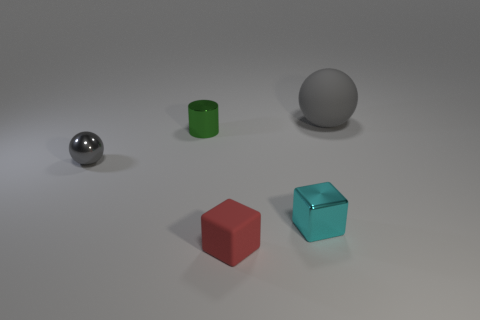What material is the other tiny ball that is the same color as the rubber ball?
Keep it short and to the point. Metal. What shape is the thing that is both on the right side of the small matte block and in front of the small gray shiny thing?
Your answer should be very brief. Cube. What is the cube that is left of the shiny thing that is on the right side of the green shiny cylinder made of?
Offer a terse response. Rubber. Are there more tiny objects than large balls?
Make the answer very short. Yes. Does the small rubber thing have the same color as the tiny metallic block?
Your response must be concise. No. What material is the green thing that is the same size as the gray metallic ball?
Give a very brief answer. Metal. Is the large gray object made of the same material as the small cyan thing?
Your response must be concise. No. How many large purple cubes have the same material as the green cylinder?
Offer a very short reply. 0. What number of things are gray objects on the left side of the tiny rubber block or cubes that are to the right of the red block?
Provide a succinct answer. 2. Are there more gray metallic balls in front of the small rubber block than cylinders that are on the right side of the large ball?
Keep it short and to the point. No. 